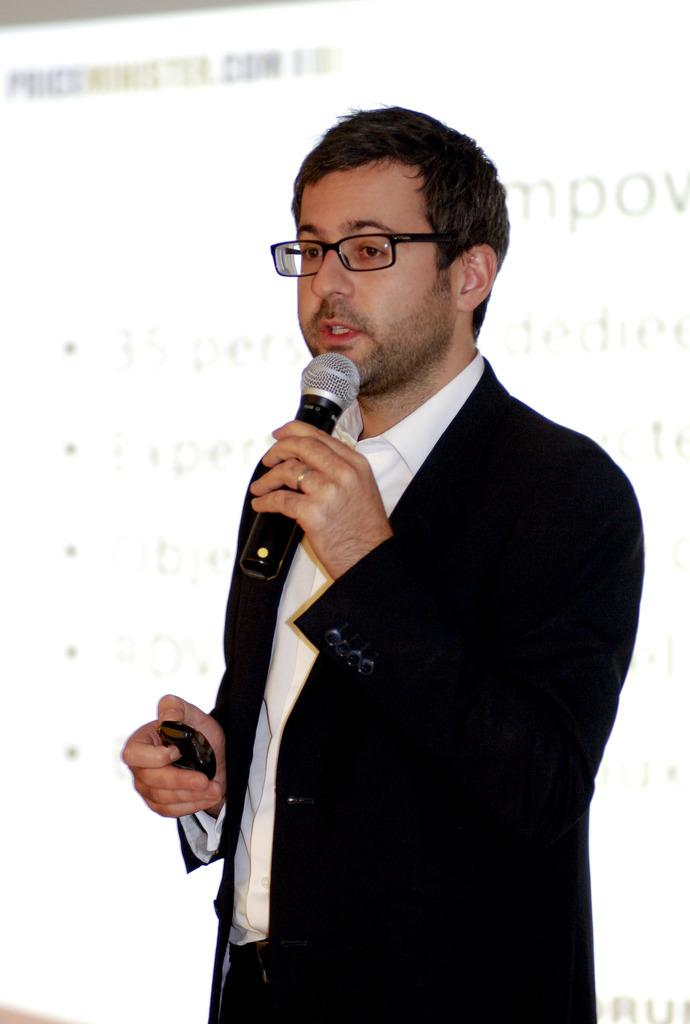What is the main subject of the image? There is a person in the image. Can you describe the person's appearance? The person is wearing clothes and spectacles. What is the person holding in the image? The person is holding a mic. What can be seen behind the person? There is a screen behind the person. Can you see any feathers on the person's clothing in the image? There are no feathers visible on the person's clothing in the image. What type of beam is supporting the screen behind the person? There is no beam visible in the image; only the screen is mentioned. 